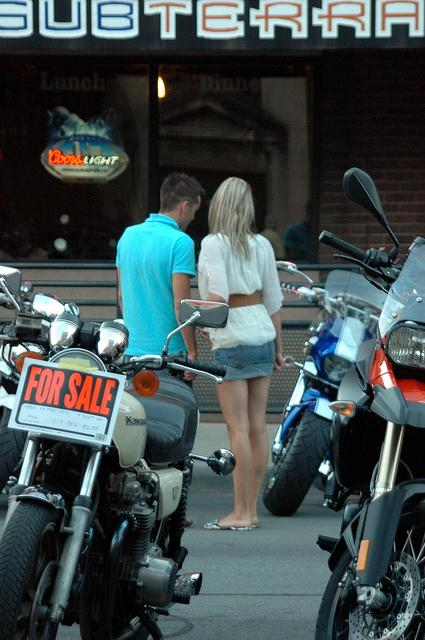What kind of shop is shown in the background? Please explain your reasoning. bar. The place sells coors light which is a beer. 